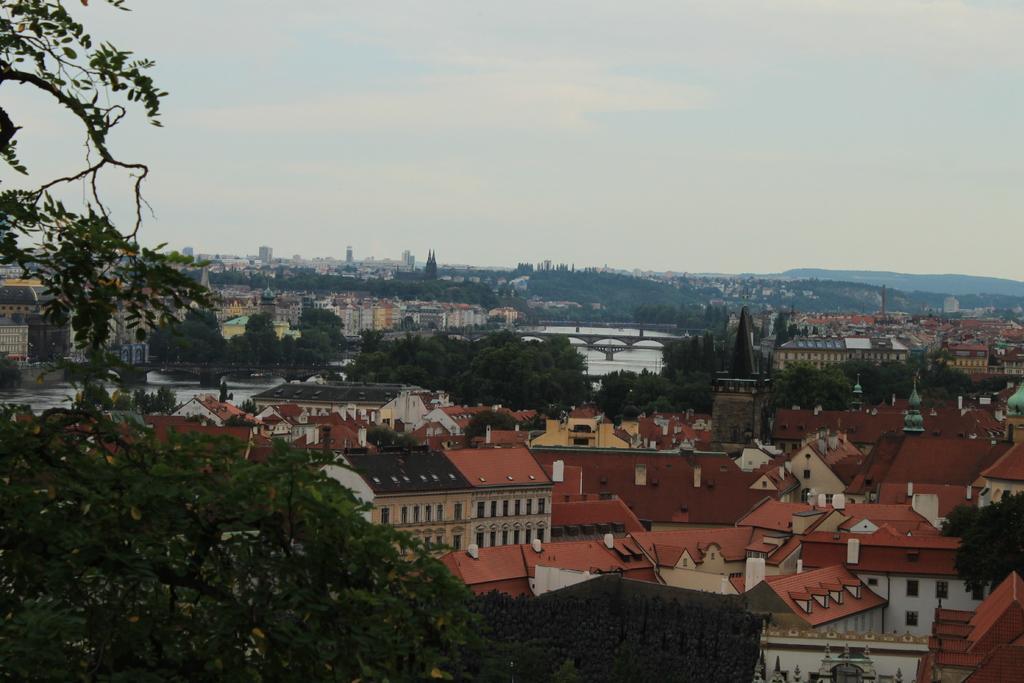Describe this image in one or two sentences. In this image we can see buildings, trees, hills and sky. 